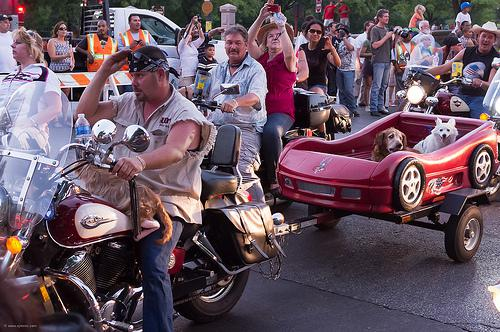Question: what is being pulled by the motorcycle?
Choices:
A. Cats.
B. Children.
C. Dogs.
D. Toys.
Answer with the letter. Answer: C Question: where are the men wearing orange vests?
Choices:
A. In the building.
B. In the restroom.
C. Inside the black car.
D. Back by white truck.
Answer with the letter. Answer: D Question: who is wearing a white shirt with arms in the air?
Choices:
A. The child.
B. Woman by white truck.
C. The old man.
D. The teenager.
Answer with the letter. Answer: B Question: what is sitting on the motorcycle with the man pulling the dogs?
Choices:
A. A child.
B. Cat.
C. A woman.
D. No one.
Answer with the letter. Answer: B Question: what are the dogs sitting in?
Choices:
A. The sidewalk.
B. Plastic car.
C. The coach.
D. The grass.
Answer with the letter. Answer: B Question: how many dogs are in the car?
Choices:
A. 3.
B. 4.
C. 5.
D. 2.
Answer with the letter. Answer: D 